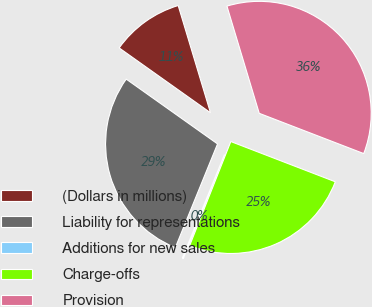Convert chart. <chart><loc_0><loc_0><loc_500><loc_500><pie_chart><fcel>(Dollars in millions)<fcel>Liability for representations<fcel>Additions for new sales<fcel>Charge-offs<fcel>Provision<nl><fcel>10.52%<fcel>28.67%<fcel>0.16%<fcel>25.14%<fcel>35.51%<nl></chart> 